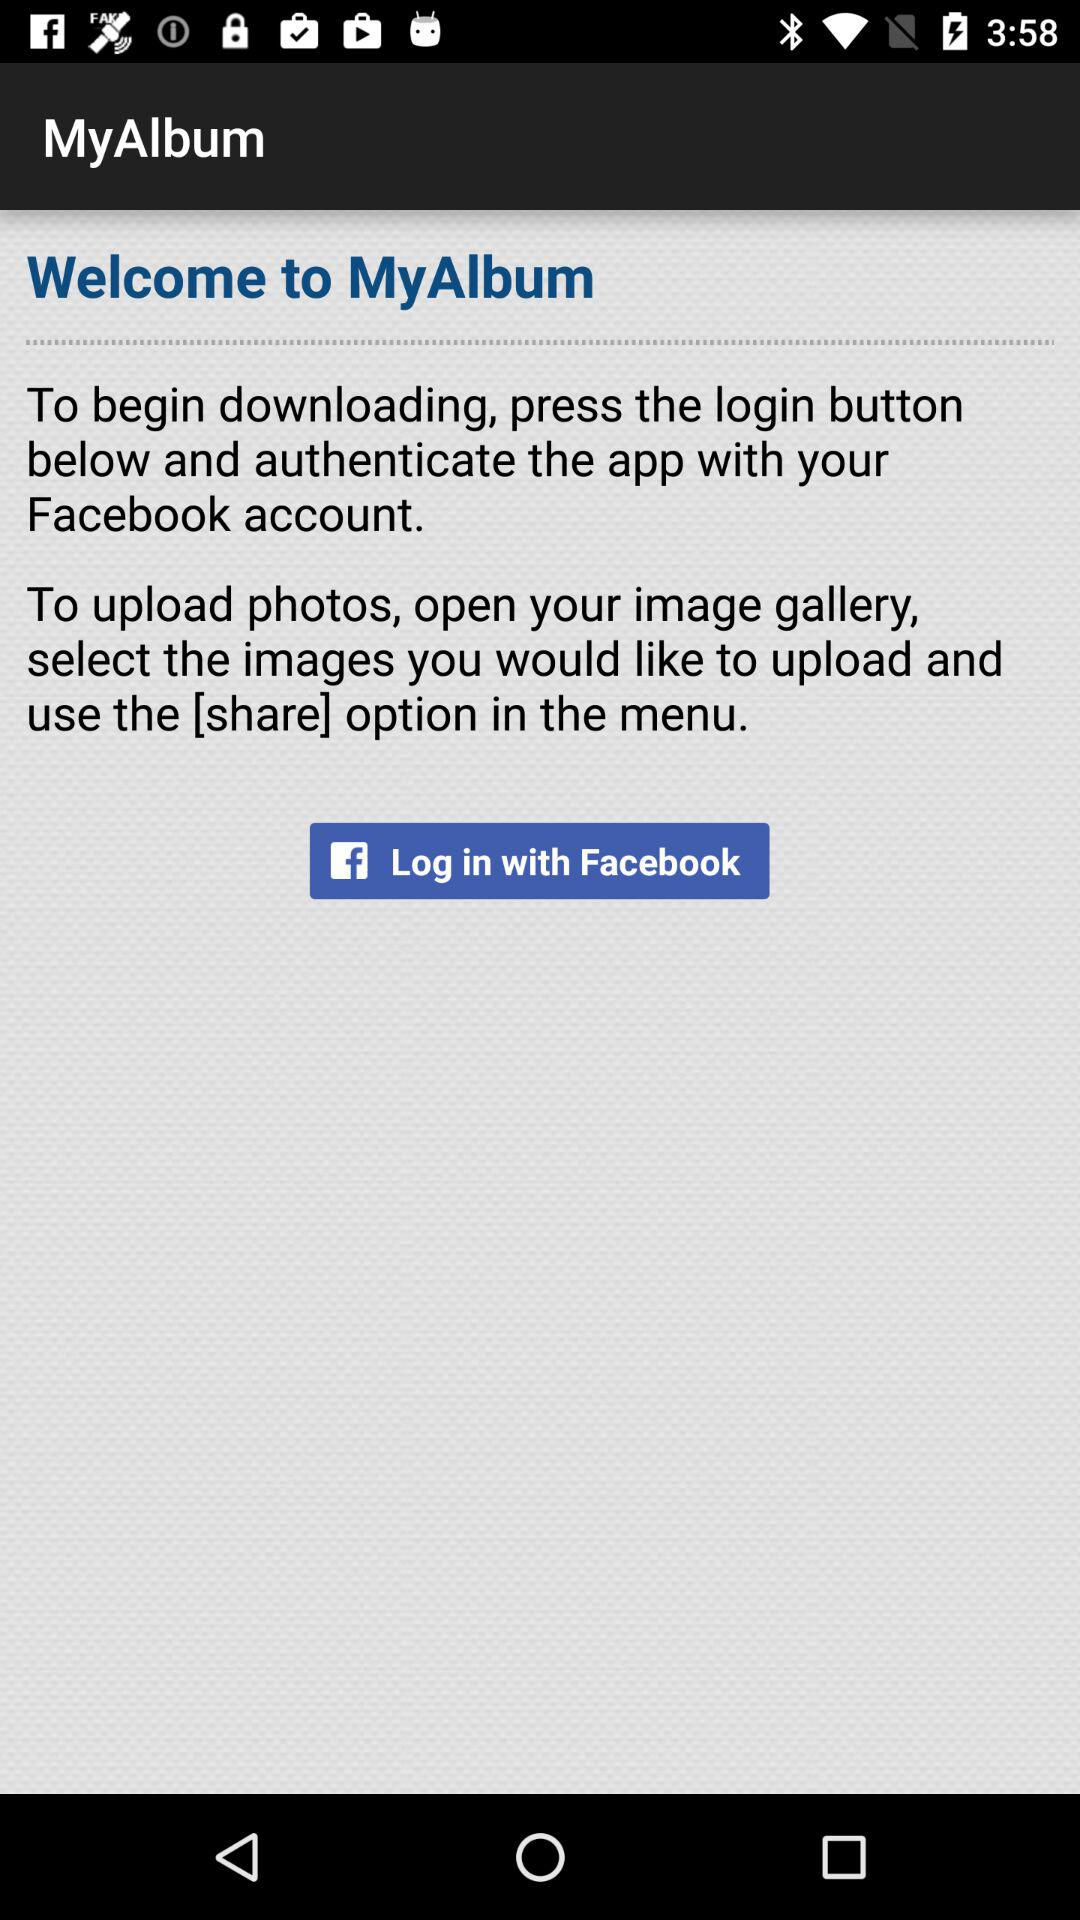What app is used for logging in? The app is "Facebook". 